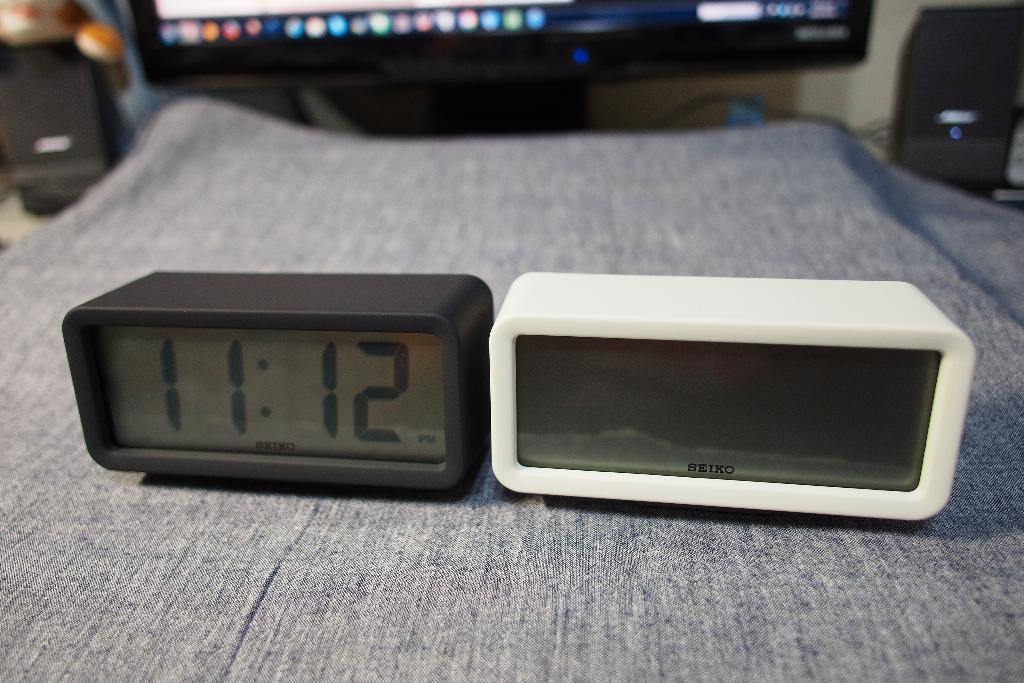Provide a one-sentence caption for the provided image. A black alarm clock reading 11:12 sits by a white alarm clock that does not have a time displayed. 